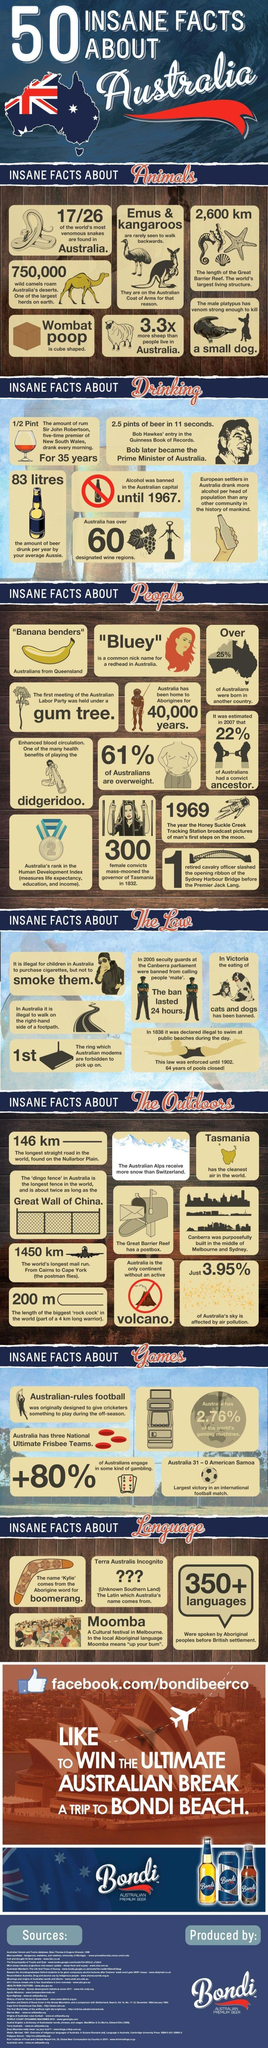List a handful of essential elements in this visual. Australia ranks second in the Human Development Index. The average Australian consumes approximately 83 liters of beer per year, according to recent statistics. According to a recent study, the state of Tasmania in Australia has been declared to have the cleanest air in the world. In 2007, it was estimated that approximately 22% of Australians had a convict ancestor. The longest straight road in the world, located on the Nullarbor Plain, has a length of 146 kilometers. 